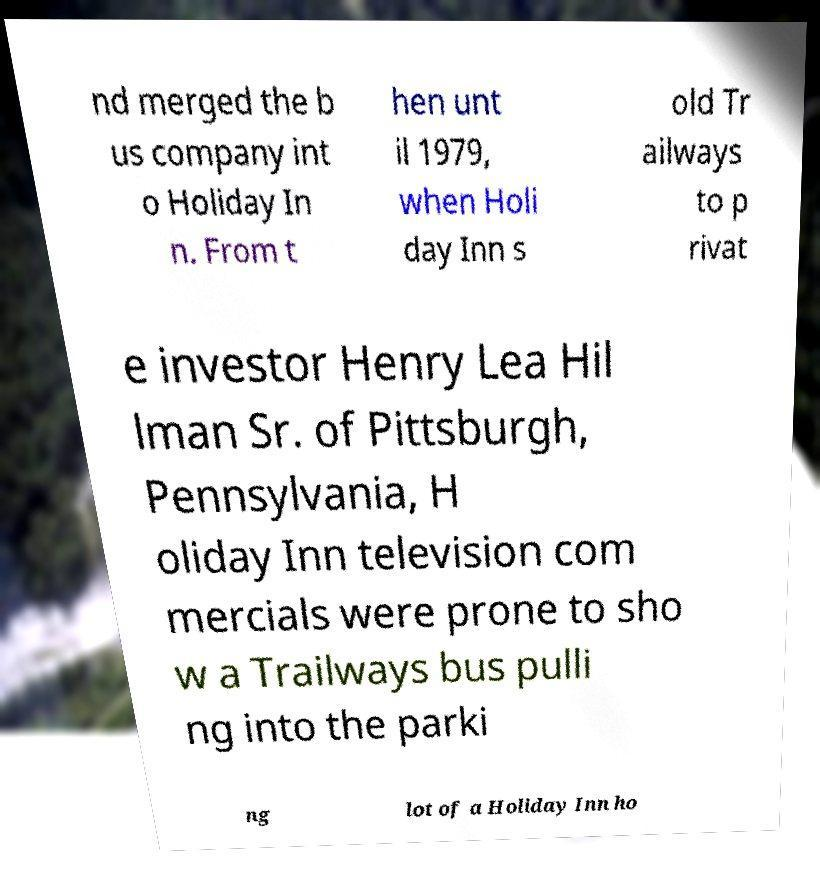Please identify and transcribe the text found in this image. nd merged the b us company int o Holiday In n. From t hen unt il 1979, when Holi day Inn s old Tr ailways to p rivat e investor Henry Lea Hil lman Sr. of Pittsburgh, Pennsylvania, H oliday Inn television com mercials were prone to sho w a Trailways bus pulli ng into the parki ng lot of a Holiday Inn ho 